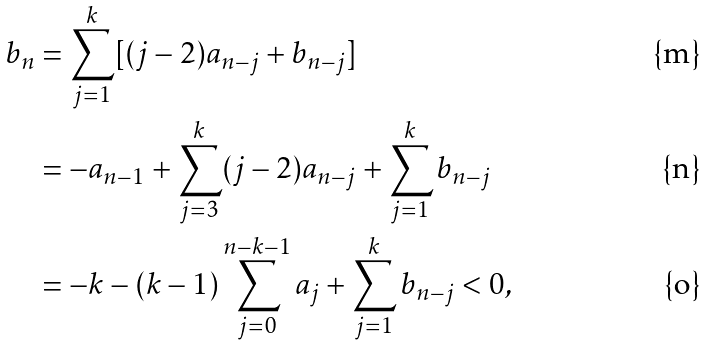Convert formula to latex. <formula><loc_0><loc_0><loc_500><loc_500>b _ { n } & = \sum _ { j = 1 } ^ { k } [ ( j - 2 ) a _ { n - j } + b _ { n - j } ] \\ & = - a _ { n - 1 } + \sum _ { j = 3 } ^ { k } ( j - 2 ) a _ { n - j } + \sum _ { j = 1 } ^ { k } b _ { n - j } \\ & = - k - ( k - 1 ) \sum _ { j = 0 } ^ { n - k - 1 } a _ { j } + \sum _ { j = 1 } ^ { k } b _ { n - j } < 0 ,</formula> 